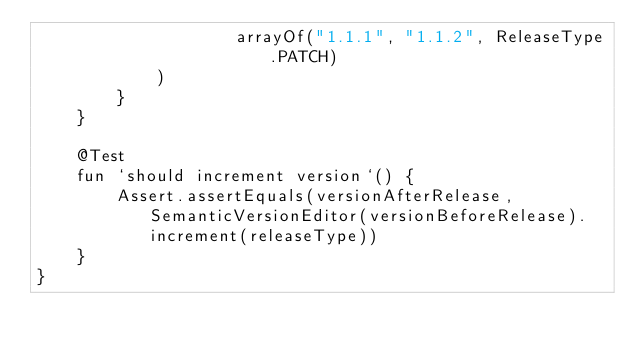Convert code to text. <code><loc_0><loc_0><loc_500><loc_500><_Kotlin_>                    arrayOf("1.1.1", "1.1.2", ReleaseType.PATCH)
            )
        }
    }

    @Test
    fun `should increment version`() {
        Assert.assertEquals(versionAfterRelease, SemanticVersionEditor(versionBeforeRelease).increment(releaseType))
    }
}</code> 